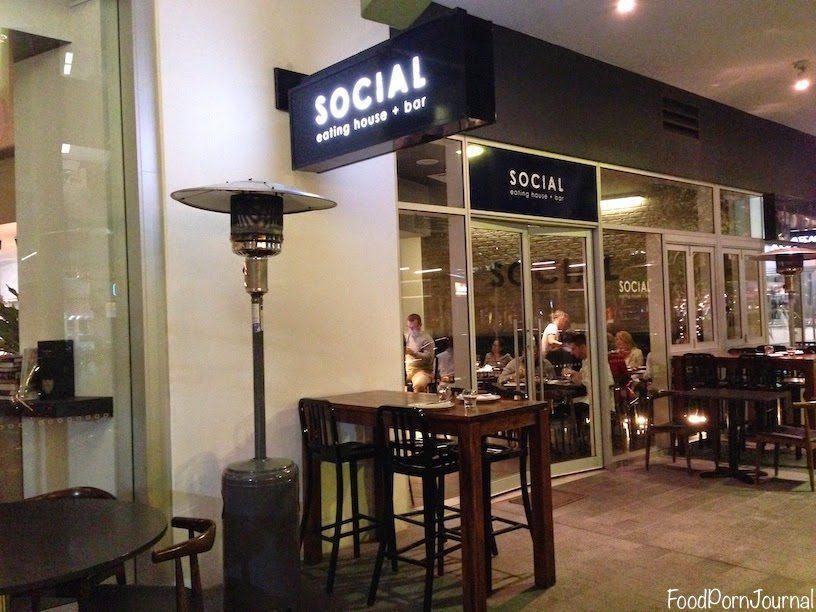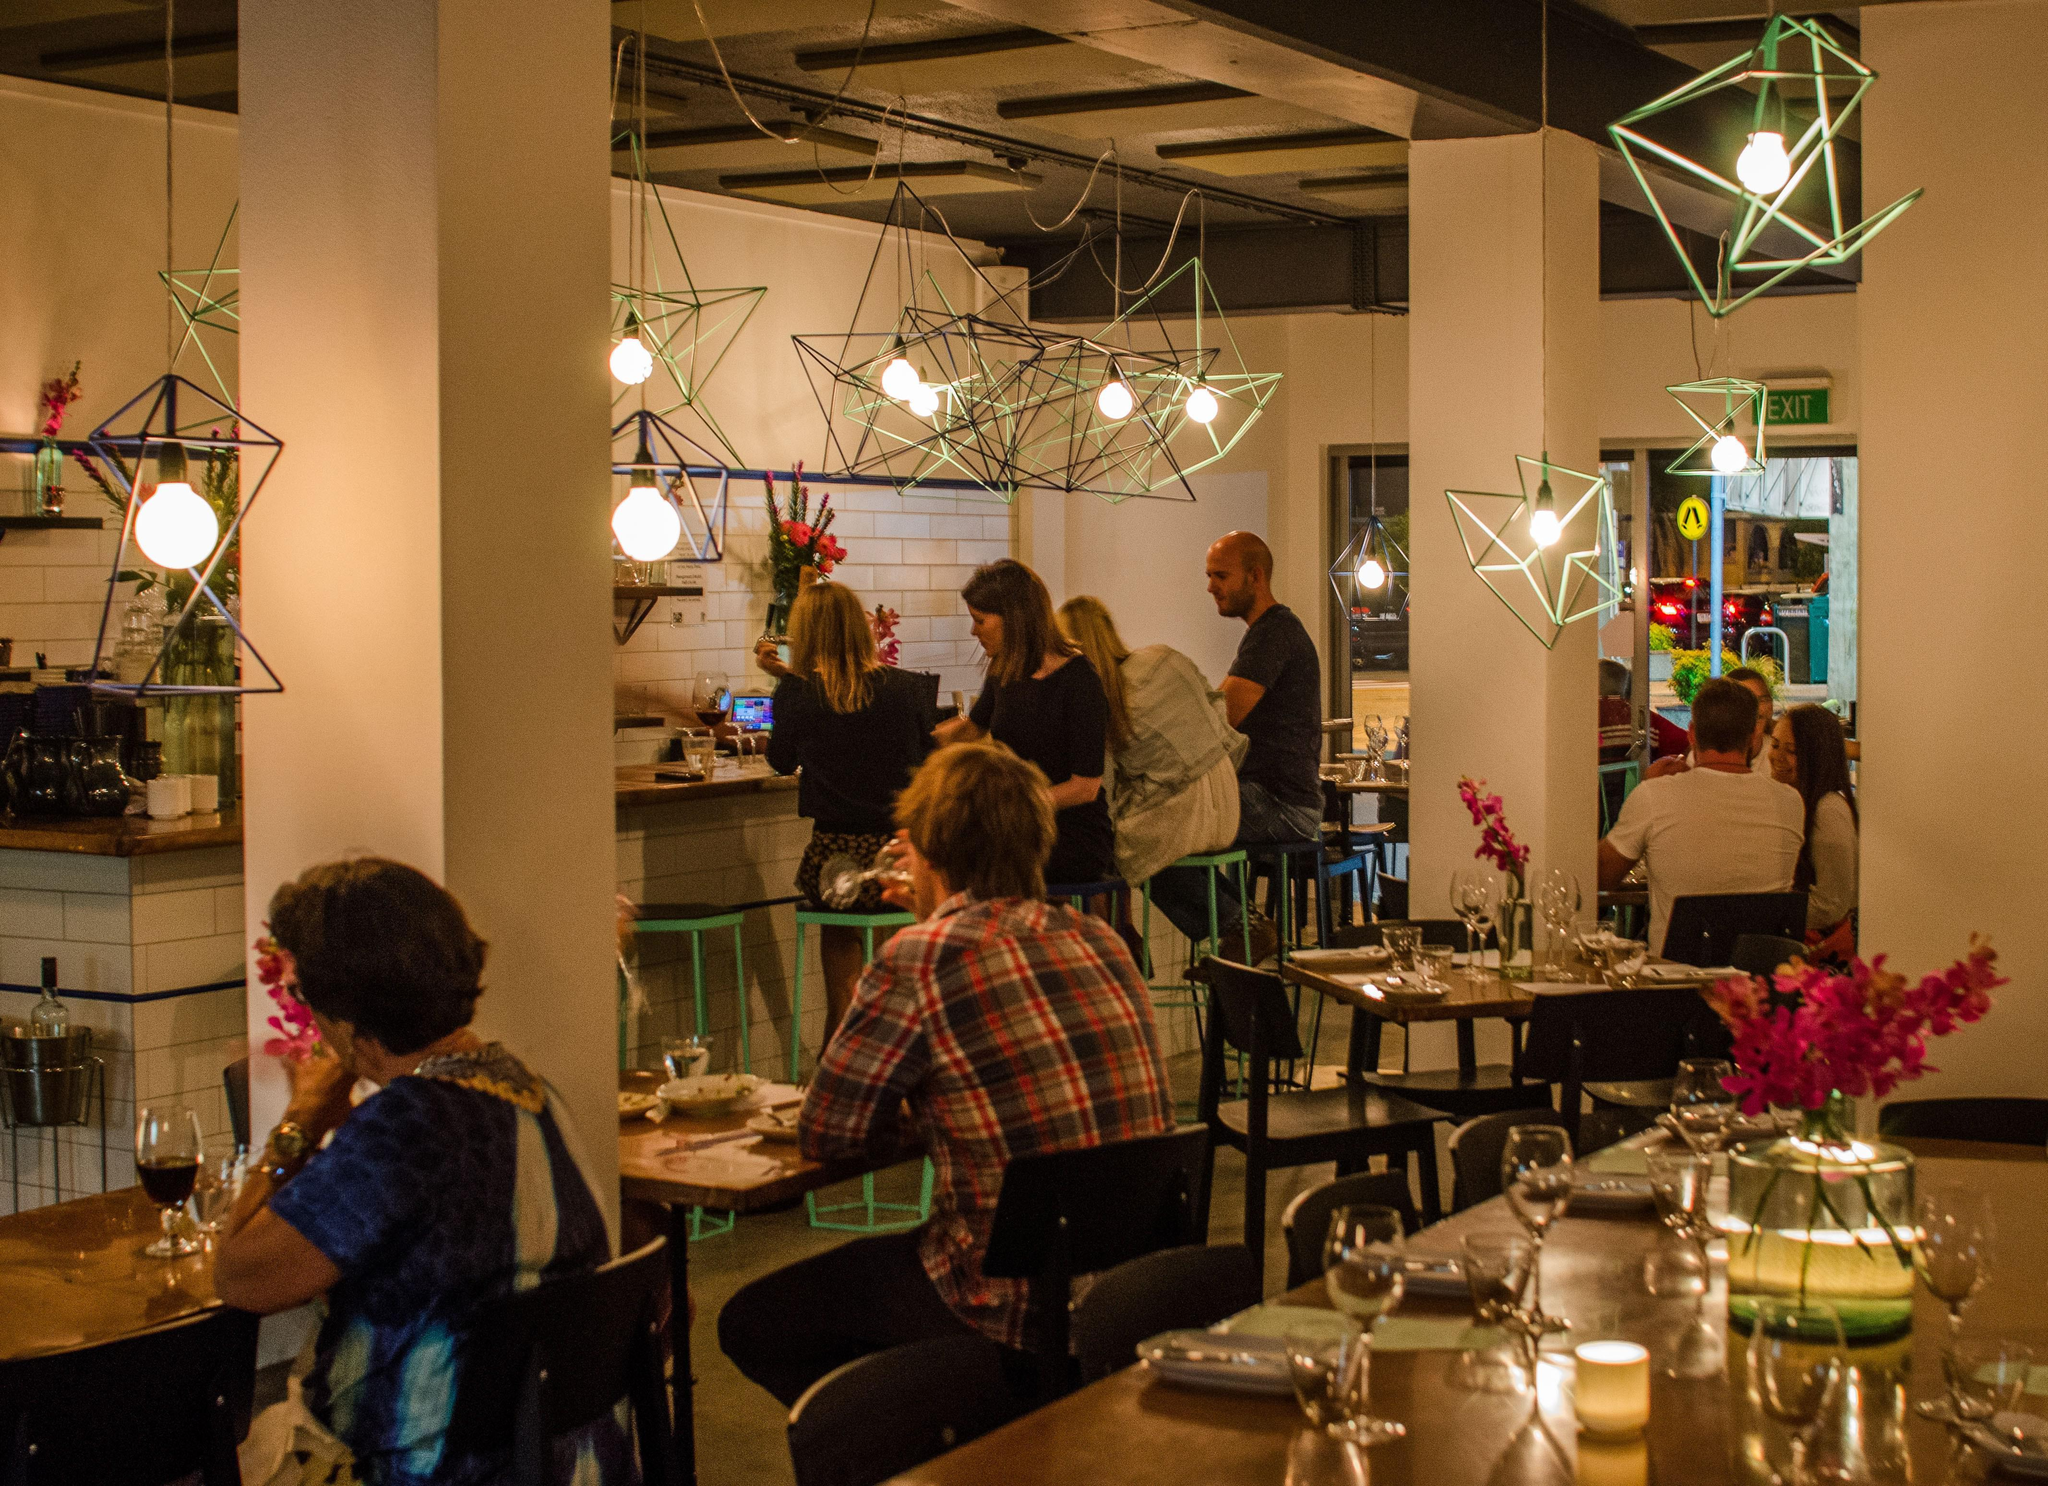The first image is the image on the left, the second image is the image on the right. Analyze the images presented: Is the assertion "There are people dining in a restaurant with exposed lit bulbs haning from the ceiling" valid? Answer yes or no. Yes. The first image is the image on the left, the second image is the image on the right. Analyze the images presented: Is the assertion "The left image shows patrons dining at an establishment that features a curve of greenish columns, with a tree visible on the exterior." valid? Answer yes or no. No. 